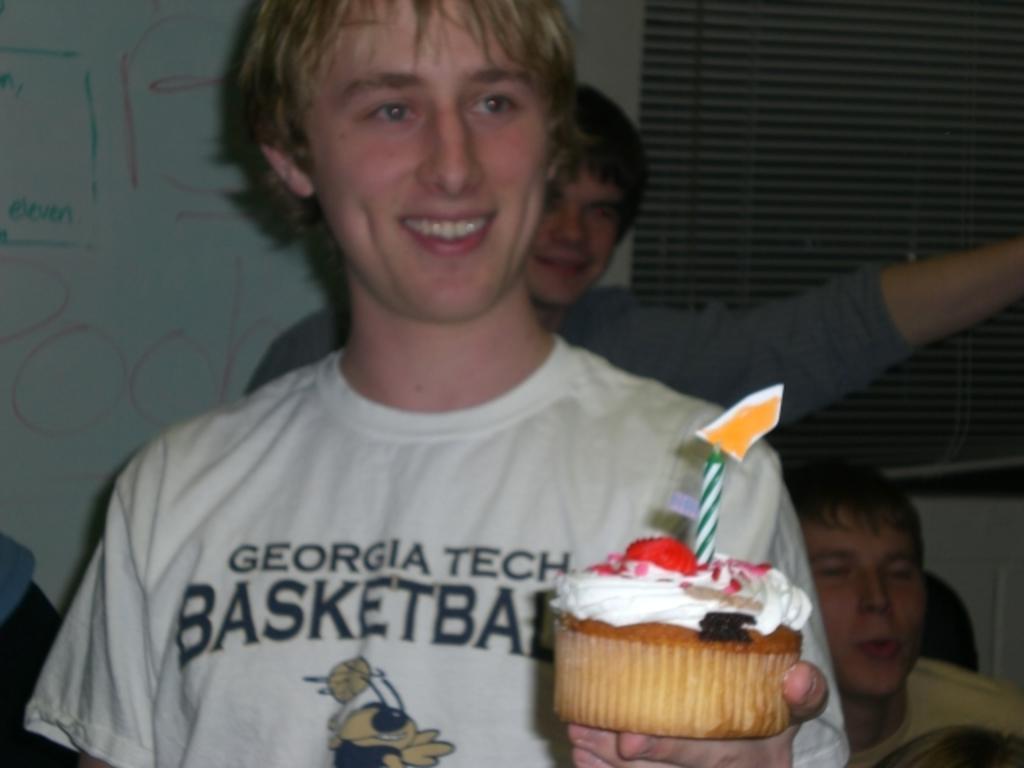How would you summarize this image in a sentence or two? In this image we can see three persons and the person who is wearing the white shirt is holding the cake with his smiling face. 